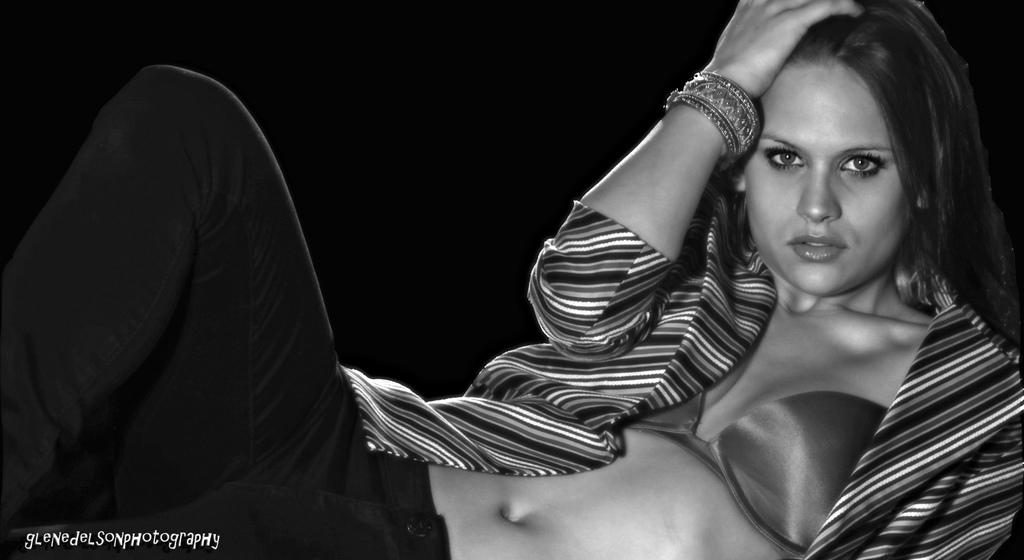Who is the main subject in the image? There is a woman in the image. What is the woman wearing? The woman is wearing a coat. How would you describe the overall appearance of the image? The background of the image is dark, and the image is in black and white. Is there any additional information or markings on the image? Yes, there is a watermark on the left side of the image. Can you tell me how many pans are visible in the image? There are no pans present in the image. Is there a dog in the image? No, there is no dog in the image. 